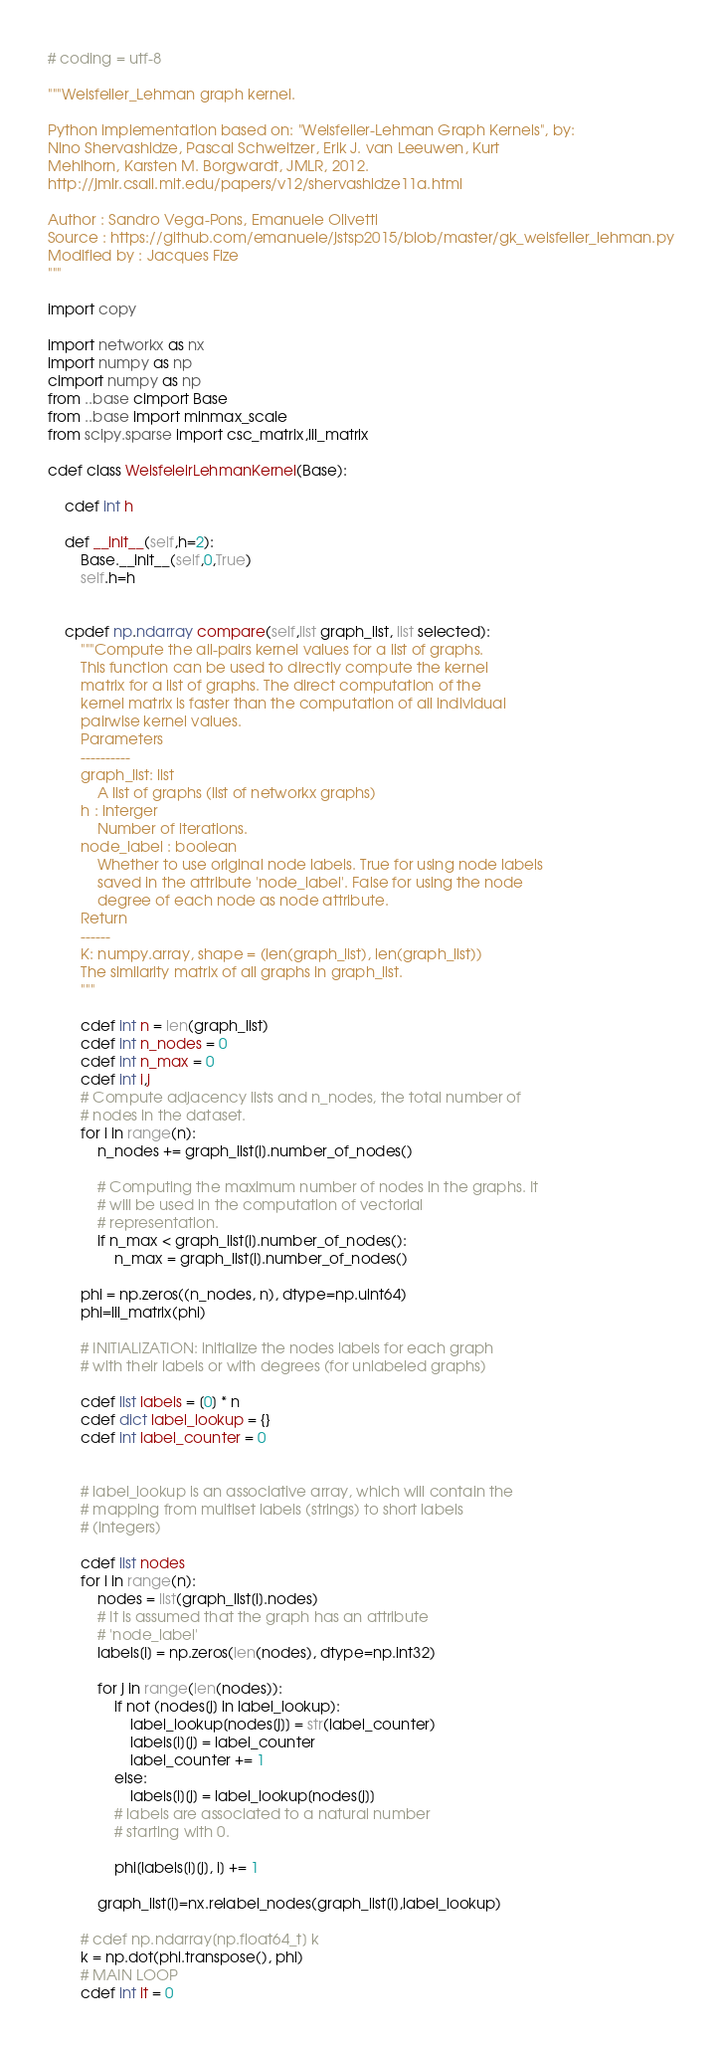<code> <loc_0><loc_0><loc_500><loc_500><_Cython_># coding = utf-8

"""Weisfeiler_Lehman graph kernel.

Python implementation based on: "Weisfeiler-Lehman Graph Kernels", by:
Nino Shervashidze, Pascal Schweitzer, Erik J. van Leeuwen, Kurt
Mehlhorn, Karsten M. Borgwardt, JMLR, 2012.
http://jmlr.csail.mit.edu/papers/v12/shervashidze11a.html

Author : Sandro Vega-Pons, Emanuele Olivetti
Source : https://github.com/emanuele/jstsp2015/blob/master/gk_weisfeiler_lehman.py
Modified by : Jacques Fize
"""

import copy

import networkx as nx
import numpy as np
cimport numpy as np
from ..base cimport Base
from ..base import minmax_scale
from scipy.sparse import csc_matrix,lil_matrix

cdef class WeisfeleirLehmanKernel(Base):

    cdef int h

    def __init__(self,h=2):
        Base.__init__(self,0,True)
        self.h=h


    cpdef np.ndarray compare(self,list graph_list, list selected):
        """Compute the all-pairs kernel values for a list of graphs.
        This function can be used to directly compute the kernel
        matrix for a list of graphs. The direct computation of the
        kernel matrix is faster than the computation of all individual
        pairwise kernel values.
        Parameters
        ----------
        graph_list: list
            A list of graphs (list of networkx graphs)
        h : interger
            Number of iterations.
        node_label : boolean
            Whether to use original node labels. True for using node labels
            saved in the attribute 'node_label'. False for using the node
            degree of each node as node attribute.
        Return
        ------
        K: numpy.array, shape = (len(graph_list), len(graph_list))
        The similarity matrix of all graphs in graph_list.
        """

        cdef int n = len(graph_list)
        cdef int n_nodes = 0
        cdef int n_max = 0
        cdef int i,j
        # Compute adjacency lists and n_nodes, the total number of
        # nodes in the dataset.
        for i in range(n):
            n_nodes += graph_list[i].number_of_nodes()

            # Computing the maximum number of nodes in the graphs. It
            # will be used in the computation of vectorial
            # representation.
            if n_max < graph_list[i].number_of_nodes():
                n_max = graph_list[i].number_of_nodes()

        phi = np.zeros((n_nodes, n), dtype=np.uint64)
        phi=lil_matrix(phi)

        # INITIALIZATION: initialize the nodes labels for each graph
        # with their labels or with degrees (for unlabeled graphs)

        cdef list labels = [0] * n
        cdef dict label_lookup = {}
        cdef int label_counter = 0


        # label_lookup is an associative array, which will contain the
        # mapping from multiset labels (strings) to short labels
        # (integers)

        cdef list nodes
        for i in range(n):
            nodes = list(graph_list[i].nodes)
            # It is assumed that the graph has an attribute
            # 'node_label'
            labels[i] = np.zeros(len(nodes), dtype=np.int32)

            for j in range(len(nodes)):
                if not (nodes[j] in label_lookup):
                    label_lookup[nodes[j]] = str(label_counter)
                    labels[i][j] = label_counter
                    label_counter += 1
                else:
                    labels[i][j] = label_lookup[nodes[j]]
                # labels are associated to a natural number
                # starting with 0.

                phi[labels[i][j], i] += 1

            graph_list[i]=nx.relabel_nodes(graph_list[i],label_lookup)

        # cdef np.ndarray[np.float64_t] k
        k = np.dot(phi.transpose(), phi)
        # MAIN LOOP
        cdef int it = 0
</code> 